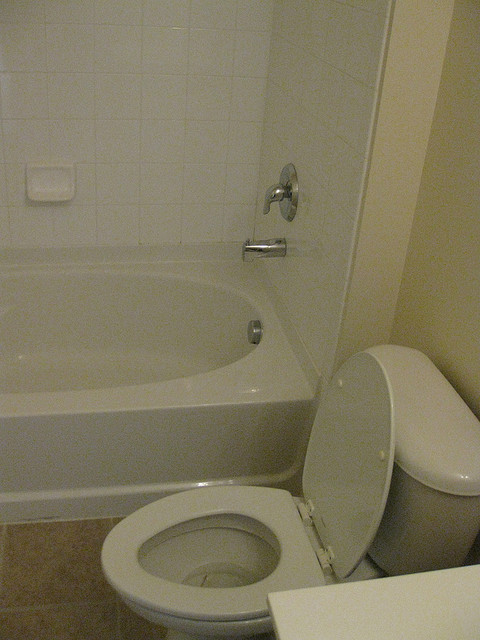<image>What is the purpose of the silver hose in the back? I don't know the exact purpose of the silver hose in the back. It might be used for water flow or to drain water. What is the purpose of the silver hose in the back? The purpose of the silver hose in the back is to transfer water. 